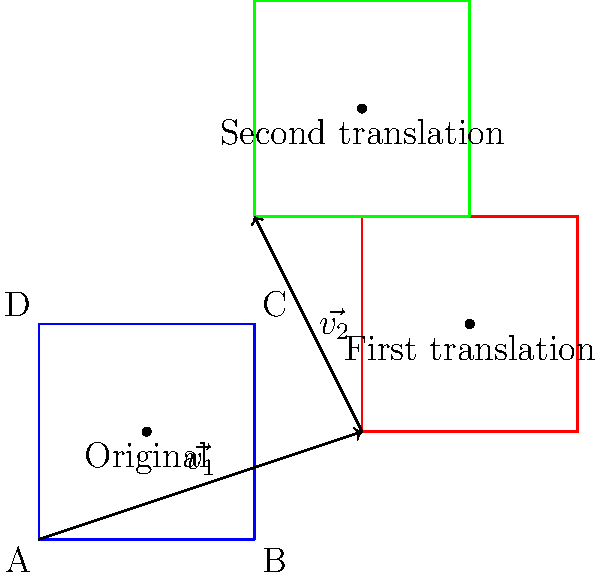As we explore the fascinating world of transformational geometry, consider the square ABCD shown in the diagram. This square undergoes two consecutive translations: first by vector $\vec{v_1} = (3,1)$, and then by vector $\vec{v_2} = (-1,2)$. What invariant properties of the square are preserved after these translations? Explain your reasoning and how this relates to the concept of rigid transformations. Let's analyze this step-by-step:

1) First, recall that a translation is a type of rigid transformation. Rigid transformations preserve certain properties of geometric figures.

2) The invariant properties of a square under translation include:

   a) Side lengths: All sides of the square remain equal in length.
   b) Angles: All internal angles remain 90 degrees.
   c) Area: The area of the square is unchanged.
   d) Shape: The overall shape remains a square.
   e) Parallelism: Opposite sides remain parallel.
   f) Orientation: The relative positioning of vertices (clockwise or counterclockwise) is maintained.

3) Let's verify these properties for our specific translations:

   - The blue square is the original.
   - The red square is the result of the first translation by $\vec{v_1} = (3,1)$.
   - The green square is the final position after the second translation by $\vec{v_2} = (-1,2)$.

4) Observe that in all three positions (blue, red, and green):
   - The squares appear congruent (same size and shape).
   - The orientation of the vertices (ABCD in clockwise order) is preserved.

5) The preservation of these properties is due to the nature of translations:
   - Translations move every point of the figure the same distance in the same direction.
   - They do not involve rotation, reflection, or scaling.

6) The concept of rigid transformations is key here. Rigid transformations (also called isometries) preserve distances between points and angles between lines. Translations, rotations, and reflections are all rigid transformations.

7) In this case, the two consecutive translations can be combined into a single translation by vector addition: $\vec{v_1} + \vec{v_2} = (3,1) + (-1,2) = (2,3)$.

This example illustrates how translations, as rigid transformations, preserve the essential geometric properties of a figure while changing its position in the plane.
Answer: Side lengths, angles, area, shape, parallelism, and orientation. 